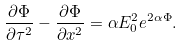<formula> <loc_0><loc_0><loc_500><loc_500>\frac { \partial \Phi } { \partial \tau ^ { 2 } } - \frac { \partial \Phi } { \partial x ^ { 2 } } = \alpha E _ { 0 } ^ { 2 } e ^ { 2 \alpha \Phi } .</formula> 